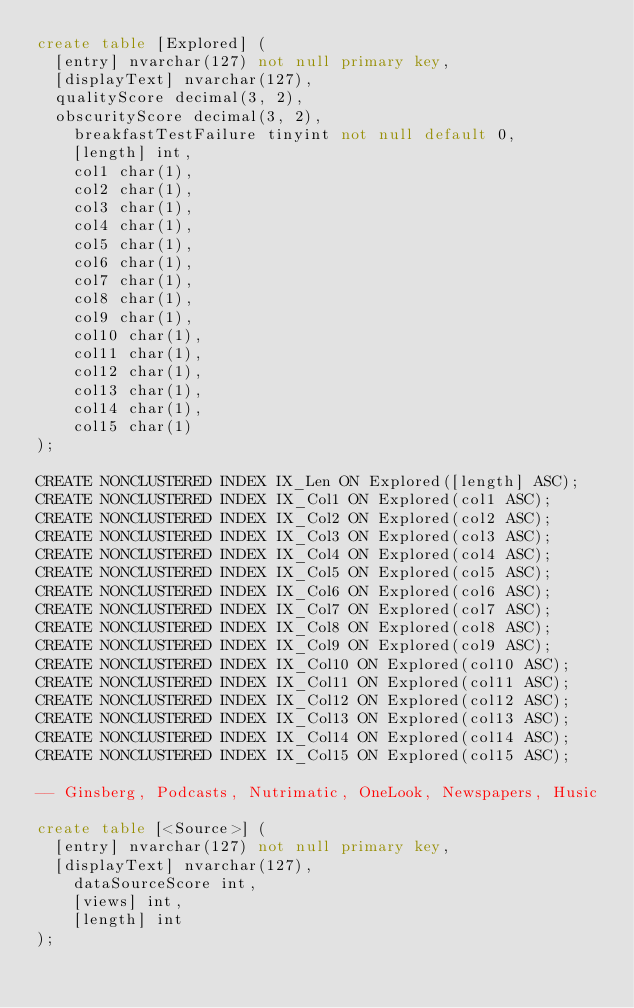<code> <loc_0><loc_0><loc_500><loc_500><_SQL_>create table [Explored] (
	[entry] nvarchar(127) not null primary key,
	[displayText] nvarchar(127),
	qualityScore decimal(3, 2),
	obscurityScore decimal(3, 2),
    breakfastTestFailure tinyint not null default 0,
    [length] int,
    col1 char(1),
    col2 char(1),
    col3 char(1),
    col4 char(1),
    col5 char(1),
    col6 char(1),
    col7 char(1),
    col8 char(1),
    col9 char(1),
    col10 char(1),
    col11 char(1),
    col12 char(1),
    col13 char(1),
    col14 char(1),
    col15 char(1)
);

CREATE NONCLUSTERED INDEX IX_Len ON Explored([length] ASC);
CREATE NONCLUSTERED INDEX IX_Col1 ON Explored(col1 ASC);
CREATE NONCLUSTERED INDEX IX_Col2 ON Explored(col2 ASC);
CREATE NONCLUSTERED INDEX IX_Col3 ON Explored(col3 ASC);
CREATE NONCLUSTERED INDEX IX_Col4 ON Explored(col4 ASC);
CREATE NONCLUSTERED INDEX IX_Col5 ON Explored(col5 ASC);
CREATE NONCLUSTERED INDEX IX_Col6 ON Explored(col6 ASC);
CREATE NONCLUSTERED INDEX IX_Col7 ON Explored(col7 ASC);
CREATE NONCLUSTERED INDEX IX_Col8 ON Explored(col8 ASC);
CREATE NONCLUSTERED INDEX IX_Col9 ON Explored(col9 ASC);
CREATE NONCLUSTERED INDEX IX_Col10 ON Explored(col10 ASC);
CREATE NONCLUSTERED INDEX IX_Col11 ON Explored(col11 ASC);
CREATE NONCLUSTERED INDEX IX_Col12 ON Explored(col12 ASC);
CREATE NONCLUSTERED INDEX IX_Col13 ON Explored(col13 ASC);
CREATE NONCLUSTERED INDEX IX_Col14 ON Explored(col14 ASC);
CREATE NONCLUSTERED INDEX IX_Col15 ON Explored(col15 ASC);

-- Ginsberg, Podcasts, Nutrimatic, OneLook, Newspapers, Husic

create table [<Source>] (
	[entry] nvarchar(127) not null primary key,
	[displayText] nvarchar(127),
    dataSourceScore int,
    [views] int,
    [length] int
);
</code> 